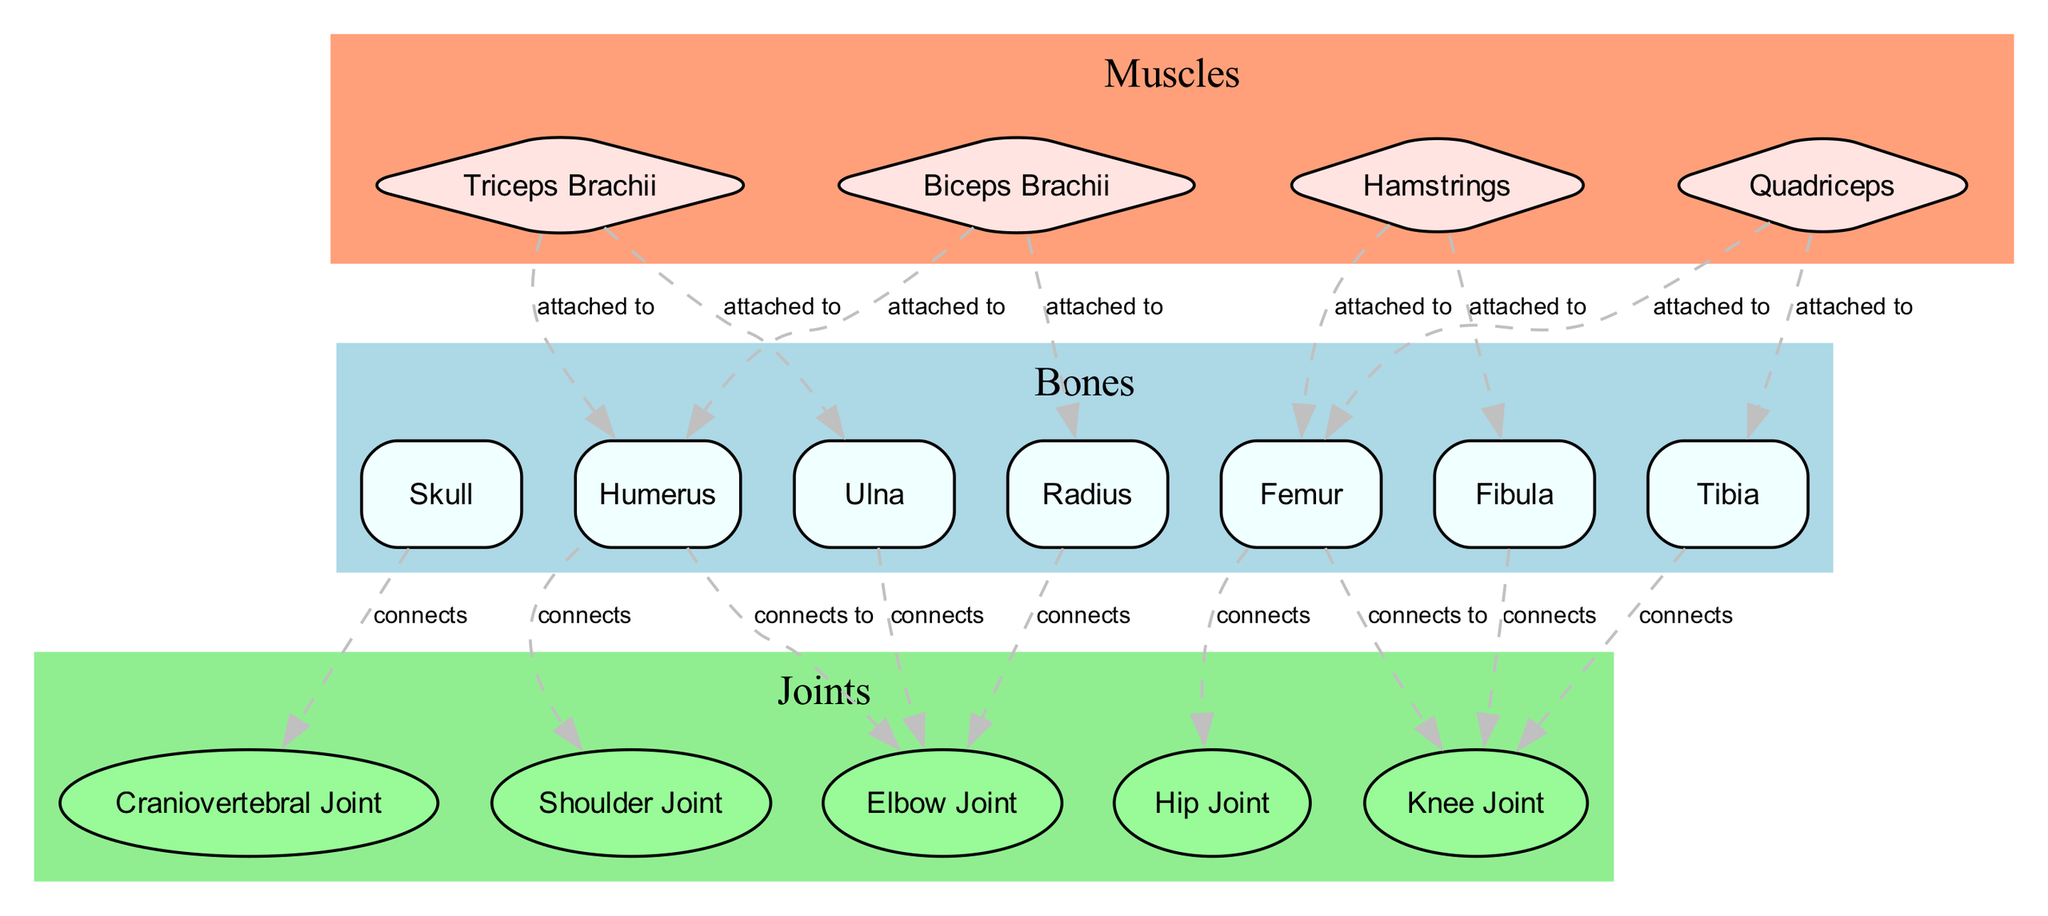What is the name of the muscle attached to the Ulna? The diagram indicates that the Triceps Brachii muscle has attachment points to the Ulna. To find this, I searched for the muscle that connects to the Ulna node, and the only one that fits is the Triceps Brachii.
Answer: Triceps Brachii How many bones are represented in the diagram? By observing the Nodes section in the diagram data, there are a total of 7 nodes classified as bones: Skull, Humerus, Radius, Ulna, Femur, Tibia, and Fibula.
Answer: 7 Which joint connects to the Femur? The diagram shows that the Hip Joint and the Knee Joint have connections to the Femur. To determine which one is the correct answer, I noted the direct attachment points shown in the Edges section. Both joints are valid, but only counting one gives me the Hip Joint as the first connection from the Femur.
Answer: Hip Joint What type of muscle is the Biceps Brachii? The diagram classifies Biceps Brachii as a Muscle. Checking its type in the diagram confirms this classification.
Answer: Muscle How many attachment points does the Quadriceps muscle have? The Quadriceps muscle is shown to be attached to two joints, the Hip Joint and the Knee Joint. I counted the attachment points listed in the Nodes for the Quadriceps to confirm both connections.
Answer: 2 Which two bones are attached to the Biceps Brachii? The Biceps Brachii muscle is indicated as being attached to two bones: the Humerus and the Radius. Referring to the Edges section, both bones are explicitly connected to the Biceps Brachii.
Answer: Humerus and Radius What is the relationship between the Skull and the Craniovertebral Joint? The diagram establishes a connection between these two nodes, specifically stating that the Skull 'connects' to the Craniovertebral Joint. By examining the Edges section, I noted this relationship is clearly labeled as "connects".
Answer: connects Which joint has the greatest number of muscle attachments? The Knee Joint has attachments from two muscles: Quadriceps and Hamstrings, making it the joint with the greatest number of muscle attachments in the diagram. By checking the attachment points for both muscles, this is confirmed.
Answer: Knee Joint 